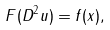Convert formula to latex. <formula><loc_0><loc_0><loc_500><loc_500>F ( D ^ { 2 } u ) = f ( x ) ,</formula> 